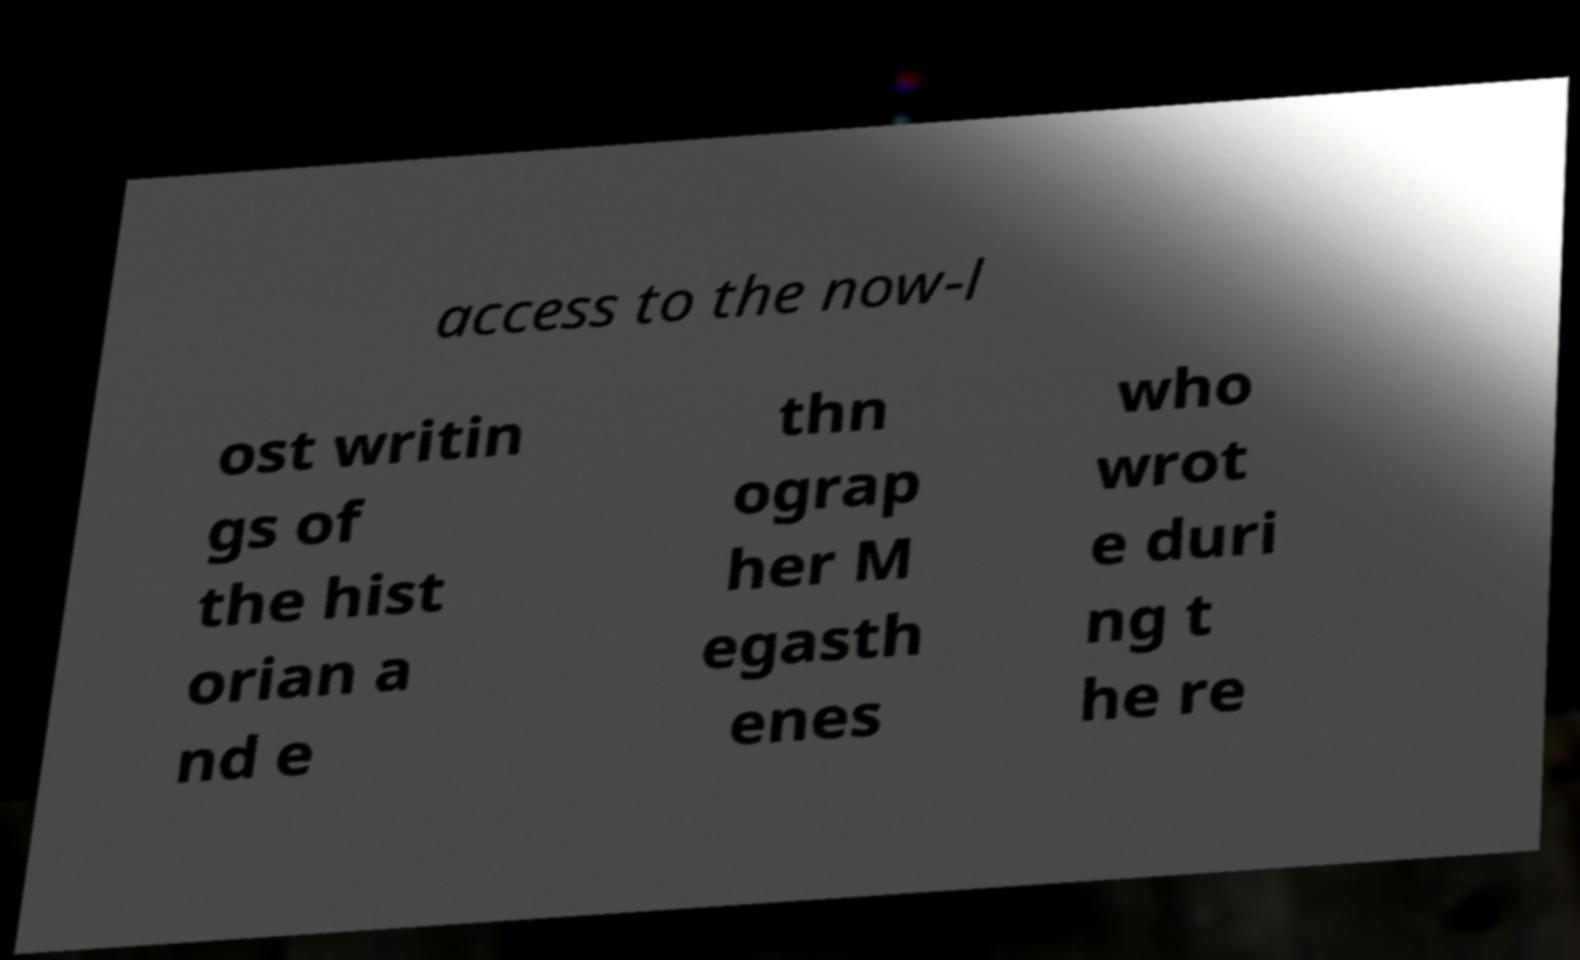Could you assist in decoding the text presented in this image and type it out clearly? access to the now-l ost writin gs of the hist orian a nd e thn ograp her M egasth enes who wrot e duri ng t he re 